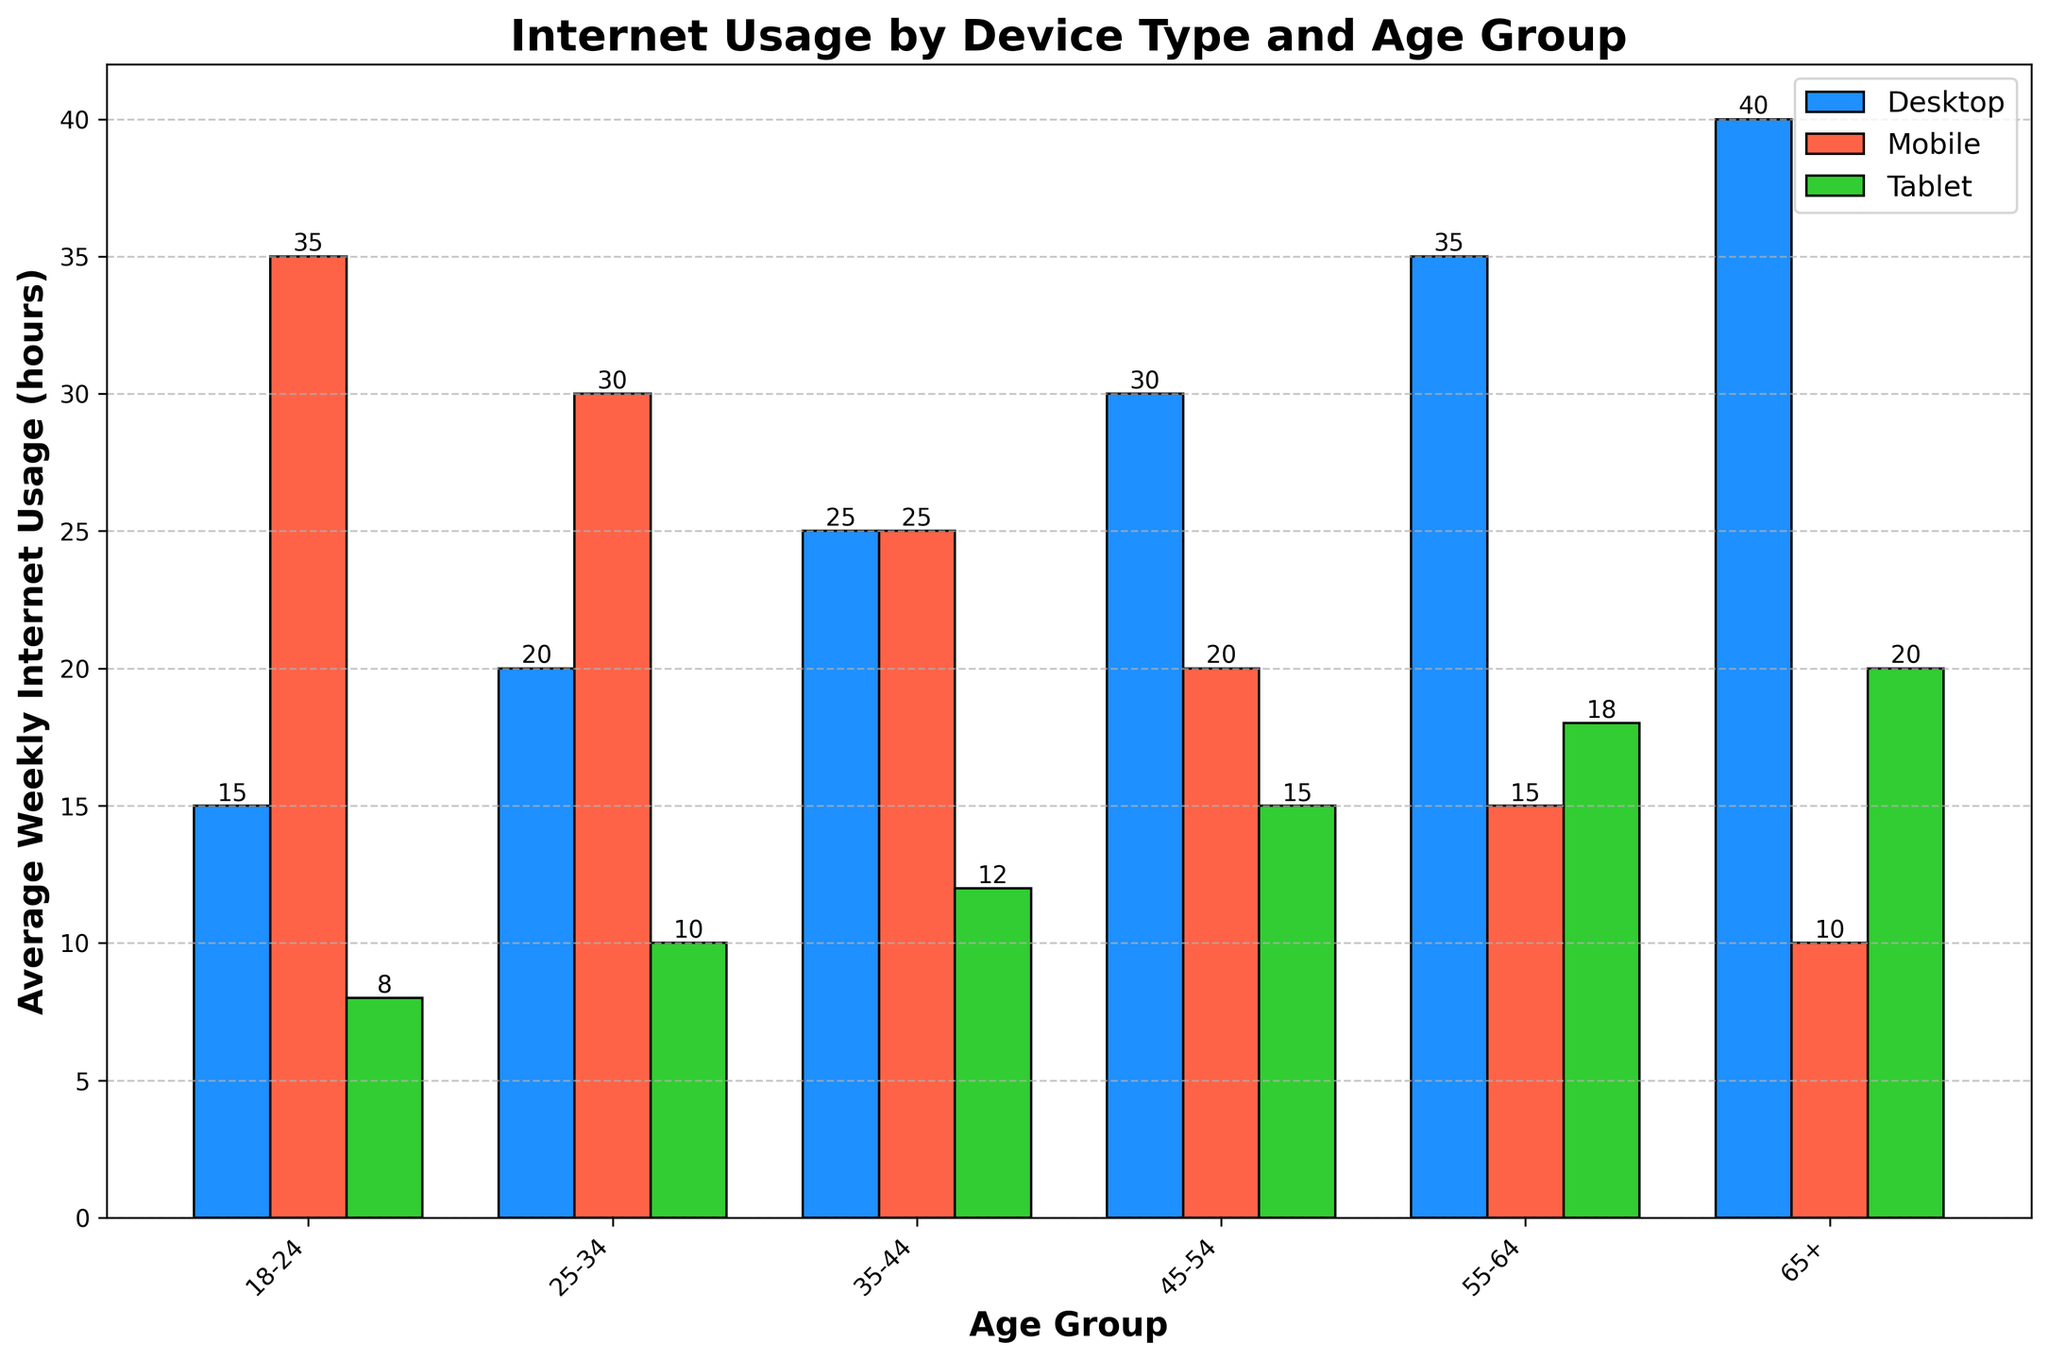Which age group has the highest average weekly internet usage on desktops? The bar representing the 65+ age group has the highest height for desktop usage, indicating they use desktops the most.
Answer: 65+ Which device type is most used by the 18-24 age group? The bar for mobile usage in the 18-24 age group is the tallest, indicating it is the most used device type in that age group.
Answer: Mobile How does the average weekly mobile usage for the 35-44 age group compare to the 55-64 age group? The mobile usage bar for the 35-44 age group is 25 hours, while for the 55-64 age group it is 15 hours, showing the 35-44 age group uses mobile devices more.
Answer: 35-44 age group uses mobile more Calculate the total average weekly internet usage (sum of desktop, mobile, and tablet) for the 45-54 age group. For the 45-54 age group: Desktop (30) + Mobile (20) + Tablet (15) = 65 hours.
Answer: 65 hours What is the average weekly internet usage on tablets across all age groups? Add up all the tablet usages: 8 + 10 + 12 + 15 + 18 + 20 = 83. Then divide by the number of age groups (6). 83 / 6 = 13.83 hours.
Answer: 13.83 hours Which age group has the most balanced usage across desktop, mobile, and tablet devices? The 35-44 age group has desktop, mobile, and tablet usages closest to each other in height (25, 25, 12), indicating the most balanced usage.
Answer: 35-44 How does the desktop usage trend change with increasing age? The height of the bars for desktop usage increases with each subsequent age group, indicating a rising trend in desktop usage with age.
Answer: Increases with age For the 25-34 age group, by how many hours does the mobile usage exceed tablet usage? Mobile usage for the 25-34 age group is 30 hours, while tablet usage is 10 hours. The difference is 30 - 10 = 20 hours.
Answer: 20 hours 